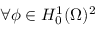<formula> <loc_0><loc_0><loc_500><loc_500>\forall \phi \in H _ { 0 } ^ { 1 } ( \Omega ) ^ { 2 } \,</formula> 